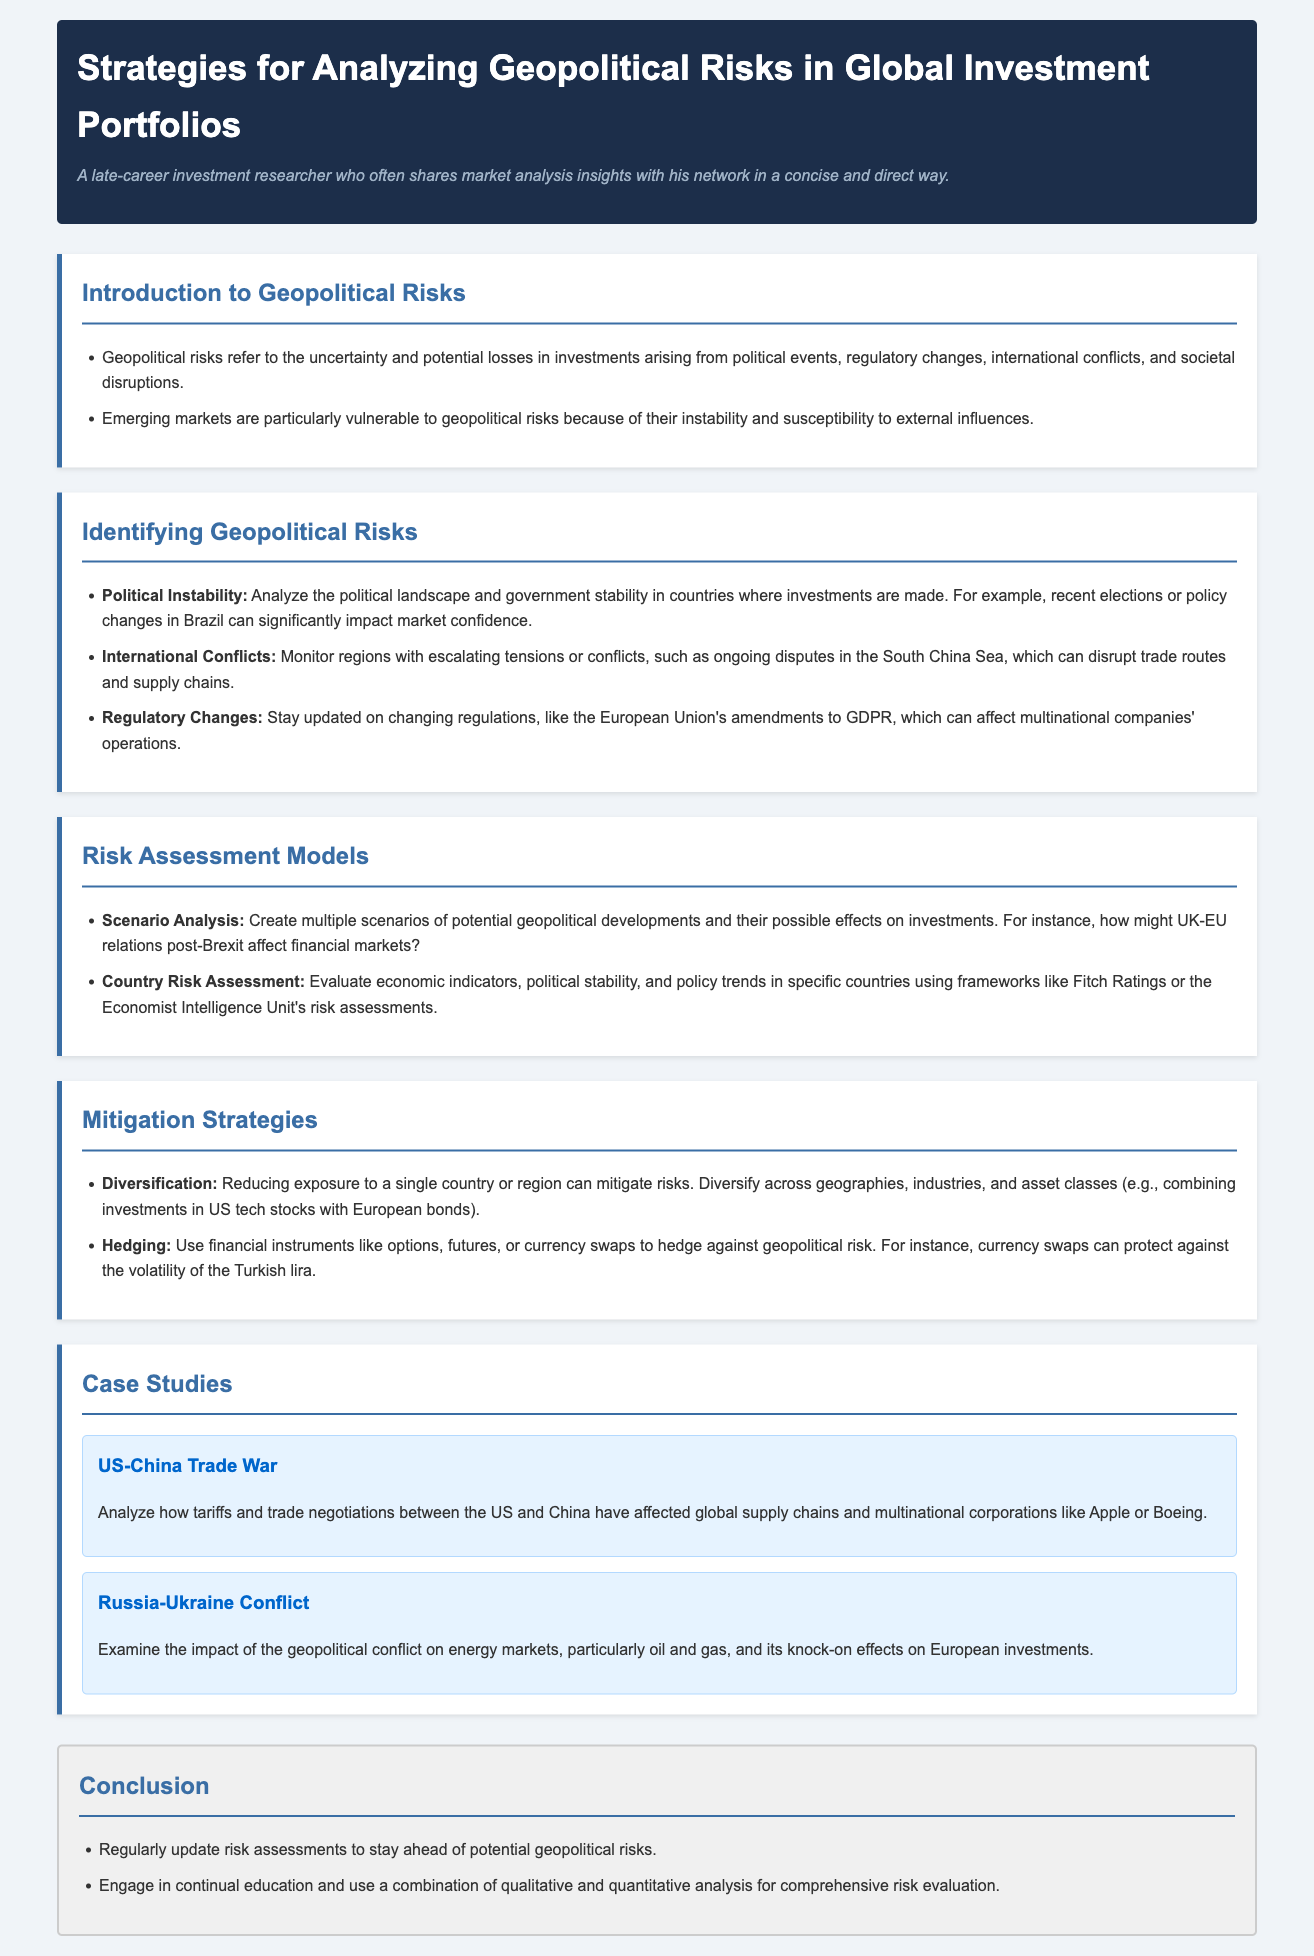What are geopolitical risks? Geopolitical risks refer to the uncertainty and potential losses in investments arising from political events, regulatory changes, international conflicts, and societal disruptions.
Answer: Uncertainty and potential losses Which markets are particularly vulnerable to geopolitical risks? The document discusses that emerging markets are particularly vulnerable to geopolitical risks due to their instability and susceptibility to external influences.
Answer: Emerging markets What is an example of political instability? The example of recent elections or policy changes in Brazil significantly impacting market confidence illustrates political instability.
Answer: Brazil What does scenario analysis involve? Scenario analysis involves creating multiple scenarios of potential geopolitical developments and their possible effects on investments.
Answer: Creating multiple scenarios Name one mitigation strategy mentioned. Diversification and hedging are both mentioned as strategies to mitigate risks in the document. As the question requests for one, diversification is selected.
Answer: Diversification What is the impact of the US-China trade war? The document focuses on analyzing how tariffs and trade negotiations between the US and China have affected global supply chains and multinational corporations.
Answer: Global supply chains How should risk assessments be updated? The conclusion suggests that risk assessments should be regularly updated to stay ahead of potential geopolitical risks.
Answer: Regularly update What frameworks can be used for country risk assessment? Frameworks such as Fitch Ratings or the Economist Intelligence Unit's risk assessments can be used for country risk assessment, as mentioned in the document.
Answer: Fitch Ratings What is examined in the case study about the Russia-Ukraine conflict? The case study examines the impact of the geopolitical conflict on energy markets, particularly oil and gas.
Answer: Energy markets 